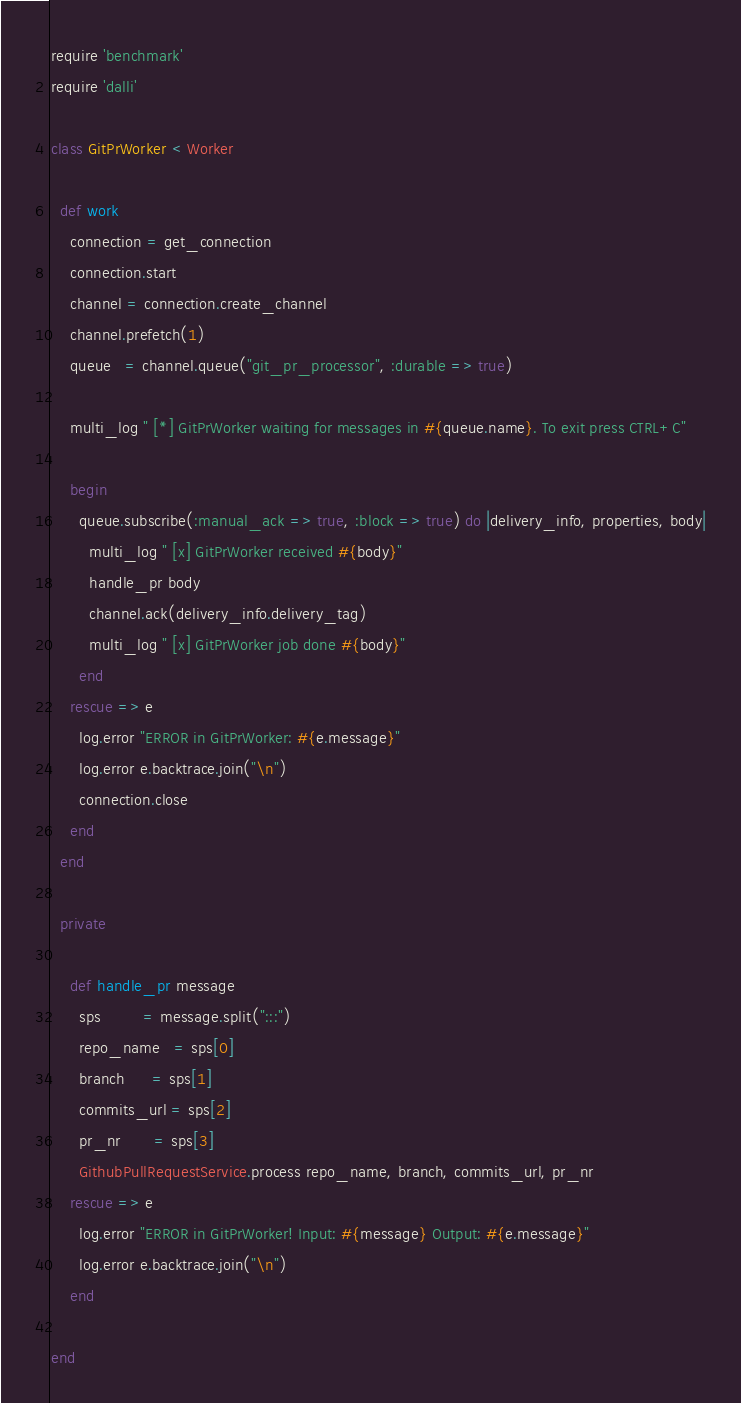<code> <loc_0><loc_0><loc_500><loc_500><_Ruby_>require 'benchmark'
require 'dalli'

class GitPrWorker < Worker

  def work
    connection = get_connection
    connection.start
    channel = connection.create_channel
    channel.prefetch(1)
    queue   = channel.queue("git_pr_processor", :durable => true)

    multi_log " [*] GitPrWorker waiting for messages in #{queue.name}. To exit press CTRL+C"

    begin
      queue.subscribe(:manual_ack => true, :block => true) do |delivery_info, properties, body|
        multi_log " [x] GitPrWorker received #{body}"
        handle_pr body
        channel.ack(delivery_info.delivery_tag)
        multi_log " [x] GitPrWorker job done #{body}"
      end
    rescue => e
      log.error "ERROR in GitPrWorker: #{e.message}"
      log.error e.backtrace.join("\n")
      connection.close
    end
  end

  private

    def handle_pr message
      sps         = message.split(":::")
      repo_name   = sps[0]
      branch      = sps[1]
      commits_url = sps[2]
      pr_nr       = sps[3]
      GithubPullRequestService.process repo_name, branch, commits_url, pr_nr
    rescue => e
      log.error "ERROR in GitPrWorker! Input: #{message} Output: #{e.message}"
      log.error e.backtrace.join("\n")
    end

end</code> 